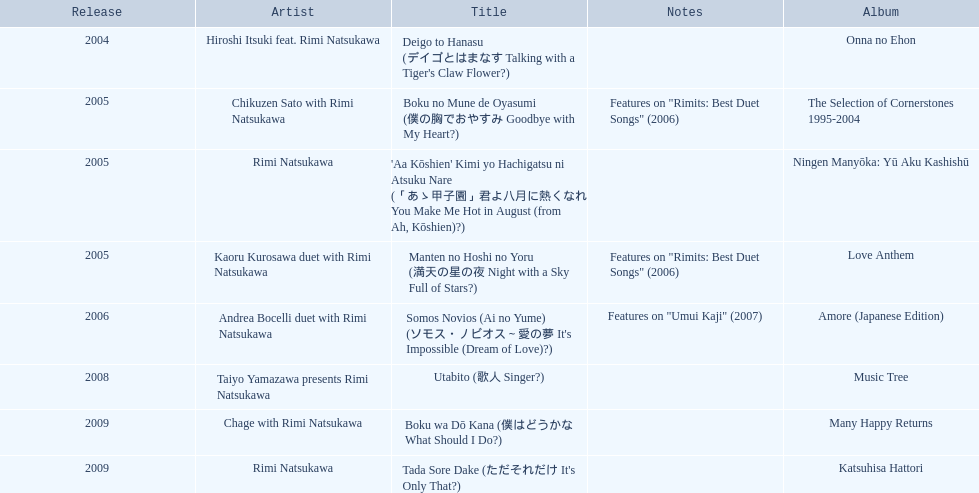What is the title of the rimi natsukawa discography released in 2004? Deigo to Hanasu (デイゴとはまなす Talking with a Tiger's Claw Flower?). Which title contains the notes present in/on "rimits: best duet songs" 2006? Manten no Hoshi no Yoru (満天の星の夜 Night with a Sky Full of Stars?). Which title has identical notes to a night with a star-filled sky? Boku no Mune de Oyasumi (僕の胸でおやすみ Goodbye with My Heart?). 